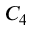Convert formula to latex. <formula><loc_0><loc_0><loc_500><loc_500>C _ { 4 }</formula> 